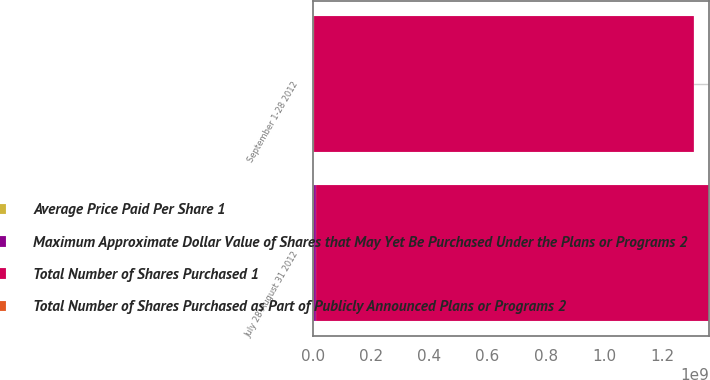Convert chart to OTSL. <chart><loc_0><loc_0><loc_500><loc_500><stacked_bar_chart><ecel><fcel>July 28-August 31 2012<fcel>September 1-28 2012<nl><fcel>Maximum Approximate Dollar Value of Shares that May Yet Be Purchased Under the Plans or Programs 2<fcel>4.27442e+06<fcel>1.27228e+06<nl><fcel>Total Number of Shares Purchased as Part of Publicly Announced Plans or Programs 2<fcel>34.63<fcel>35.81<nl><fcel>Average Price Paid Per Share 1<fcel>4.2728e+06<fcel>1.27205e+06<nl><fcel>Total Number of Shares Purchased 1<fcel>1.35264e+09<fcel>1.3071e+09<nl></chart> 